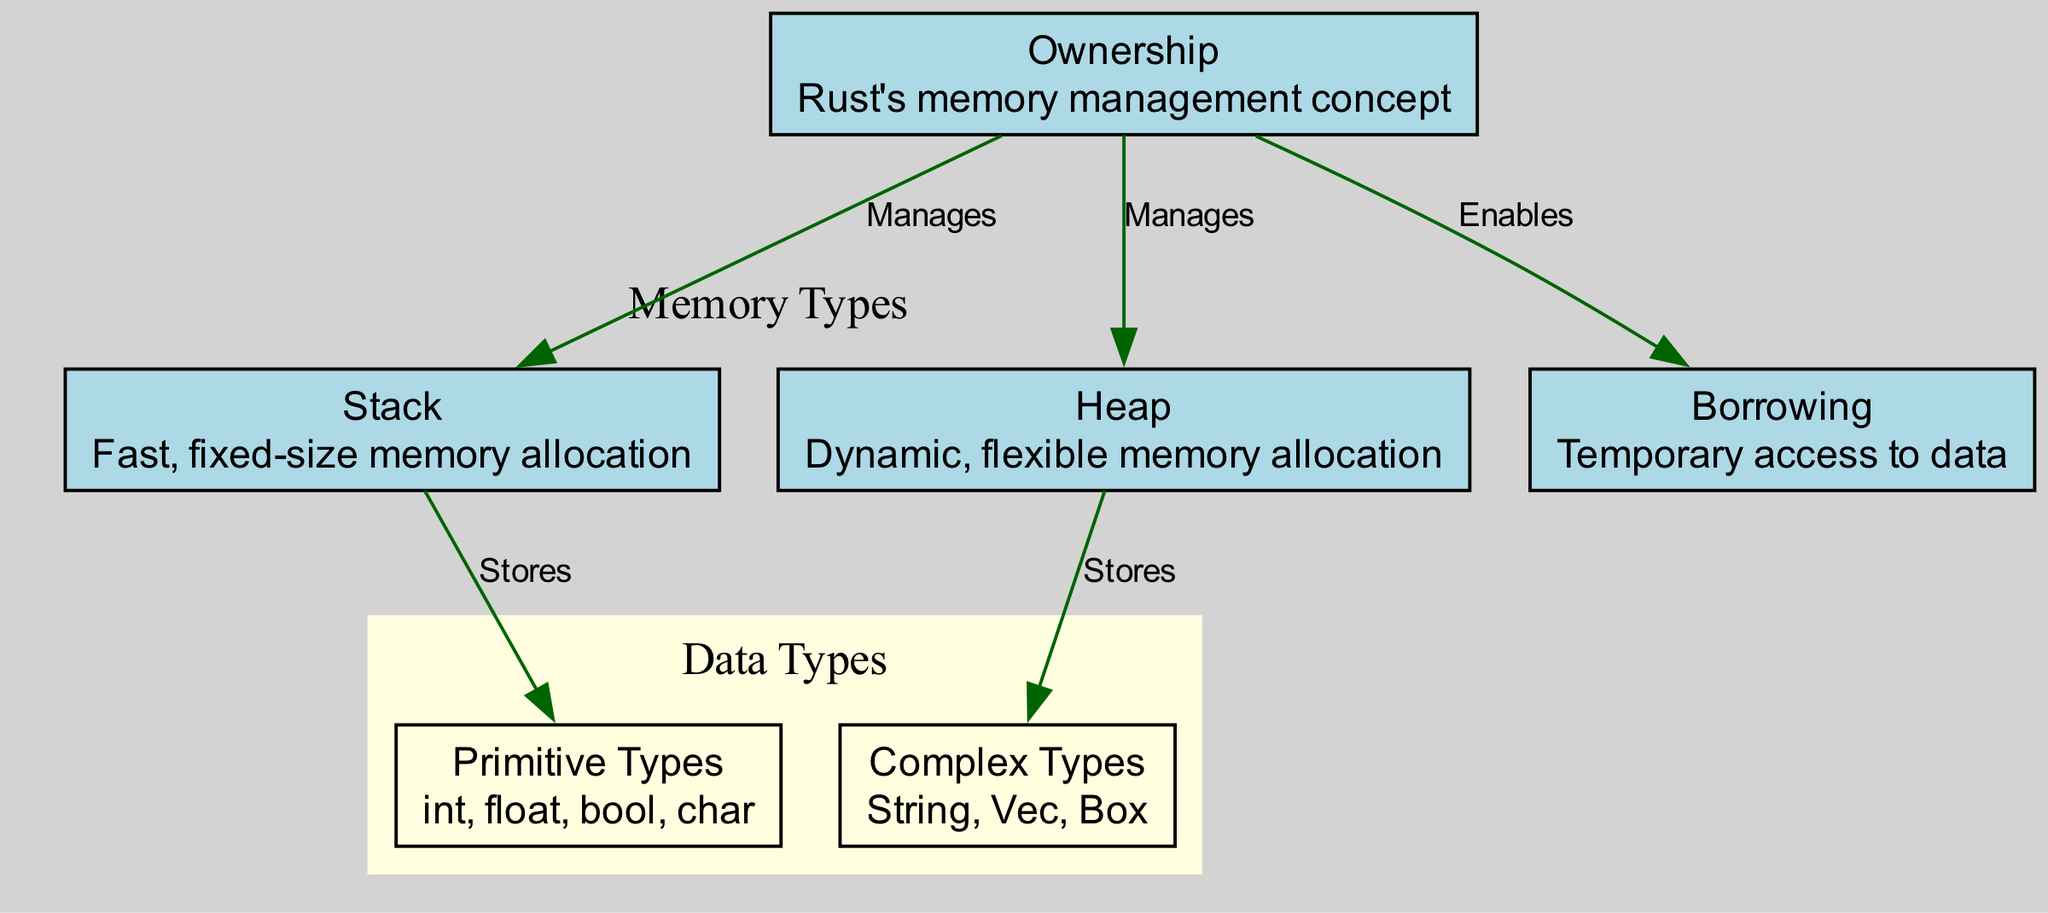What are the two types of memory allocation illustrated in the diagram? The diagram shows two specific types of memory allocation: "Stack" and "Heap." These are explicitly labeled nodes in the diagram representing different memory management strategies in Rust.
Answer: Stack and Heap How many edges are in the diagram? By counting the connections (edges) between the nodes, there are a total of five edges connecting different nodes in the diagram.
Answer: 5 What concept manages both stack and heap? The "Ownership" node is connected to both the "Stack" and "Heap" nodes, indicating that it governs or manages both types of memory allocation in Rust.
Answer: Ownership Which type of types does the Stack store? The "Stack" node has a direct edge to the "Primitive Types" node, indicating that it is used for storing primitive types like integers and booleans.
Answer: Primitive Types What concept enables borrowing in Rust? The "Ownership" node enables the concept of "Borrowing" as depicted by the directed edge between them, showing its role in allowing temporary access to data.
Answer: Borrowing How are Complex Types stored according to the diagram? The "Heap" node connects to the "Complex Types" node, illustrating that complex data structures like Strings and Vectors are allocated on the heap in Rust.
Answer: Complex Types What type of memory allocation is characterized as fast and fixed-size? The "Stack" is described in the diagram as fast and fixed-size memory allocation, distinguishing it from the more flexible heap.
Answer: Stack What type of memory management concept is shown as a central governance? The "Ownership" represents a central concept in Rust memory management, as it manages both areas of memory allocation shown in the diagram.
Answer: Ownership 